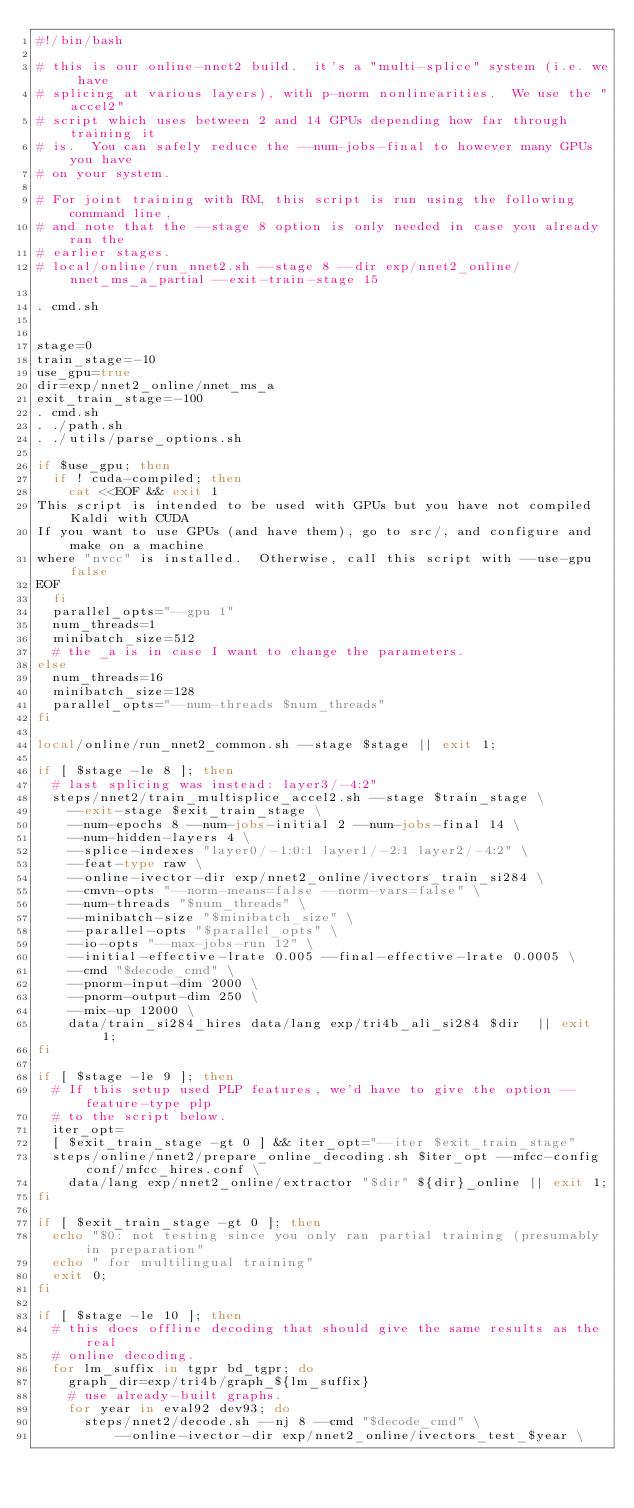<code> <loc_0><loc_0><loc_500><loc_500><_Bash_>#!/bin/bash

# this is our online-nnet2 build.  it's a "multi-splice" system (i.e. we have
# splicing at various layers), with p-norm nonlinearities.  We use the "accel2"
# script which uses between 2 and 14 GPUs depending how far through training it
# is.  You can safely reduce the --num-jobs-final to however many GPUs you have
# on your system.

# For joint training with RM, this script is run using the following command line,
# and note that the --stage 8 option is only needed in case you already ran the
# earlier stages.
# local/online/run_nnet2.sh --stage 8 --dir exp/nnet2_online/nnet_ms_a_partial --exit-train-stage 15

. cmd.sh


stage=0
train_stage=-10
use_gpu=true
dir=exp/nnet2_online/nnet_ms_a
exit_train_stage=-100
. cmd.sh
. ./path.sh
. ./utils/parse_options.sh

if $use_gpu; then
  if ! cuda-compiled; then
    cat <<EOF && exit 1 
This script is intended to be used with GPUs but you have not compiled Kaldi with CUDA 
If you want to use GPUs (and have them), go to src/, and configure and make on a machine
where "nvcc" is installed.  Otherwise, call this script with --use-gpu false
EOF
  fi
  parallel_opts="--gpu 1" 
  num_threads=1
  minibatch_size=512
  # the _a is in case I want to change the parameters.
else
  num_threads=16
  minibatch_size=128
  parallel_opts="--num-threads $num_threads" 
fi

local/online/run_nnet2_common.sh --stage $stage || exit 1;

if [ $stage -le 8 ]; then
  # last splicing was instead: layer3/-4:2" 
  steps/nnet2/train_multisplice_accel2.sh --stage $train_stage \
    --exit-stage $exit_train_stage \
    --num-epochs 8 --num-jobs-initial 2 --num-jobs-final 14 \
    --num-hidden-layers 4 \
    --splice-indexes "layer0/-1:0:1 layer1/-2:1 layer2/-4:2" \
    --feat-type raw \
    --online-ivector-dir exp/nnet2_online/ivectors_train_si284 \
    --cmvn-opts "--norm-means=false --norm-vars=false" \
    --num-threads "$num_threads" \
    --minibatch-size "$minibatch_size" \
    --parallel-opts "$parallel_opts" \
    --io-opts "--max-jobs-run 12" \
    --initial-effective-lrate 0.005 --final-effective-lrate 0.0005 \
    --cmd "$decode_cmd" \
    --pnorm-input-dim 2000 \
    --pnorm-output-dim 250 \
    --mix-up 12000 \
    data/train_si284_hires data/lang exp/tri4b_ali_si284 $dir  || exit 1;
fi

if [ $stage -le 9 ]; then
  # If this setup used PLP features, we'd have to give the option --feature-type plp
  # to the script below.
  iter_opt=
  [ $exit_train_stage -gt 0 ] && iter_opt="--iter $exit_train_stage"
  steps/online/nnet2/prepare_online_decoding.sh $iter_opt --mfcc-config conf/mfcc_hires.conf \
    data/lang exp/nnet2_online/extractor "$dir" ${dir}_online || exit 1;
fi

if [ $exit_train_stage -gt 0 ]; then
  echo "$0: not testing since you only ran partial training (presumably in preparation"
  echo " for multilingual training"
  exit 0;
fi

if [ $stage -le 10 ]; then
  # this does offline decoding that should give the same results as the real
  # online decoding.
  for lm_suffix in tgpr bd_tgpr; do
    graph_dir=exp/tri4b/graph_${lm_suffix}
    # use already-built graphs.
    for year in eval92 dev93; do
      steps/nnet2/decode.sh --nj 8 --cmd "$decode_cmd" \
          --online-ivector-dir exp/nnet2_online/ivectors_test_$year \</code> 